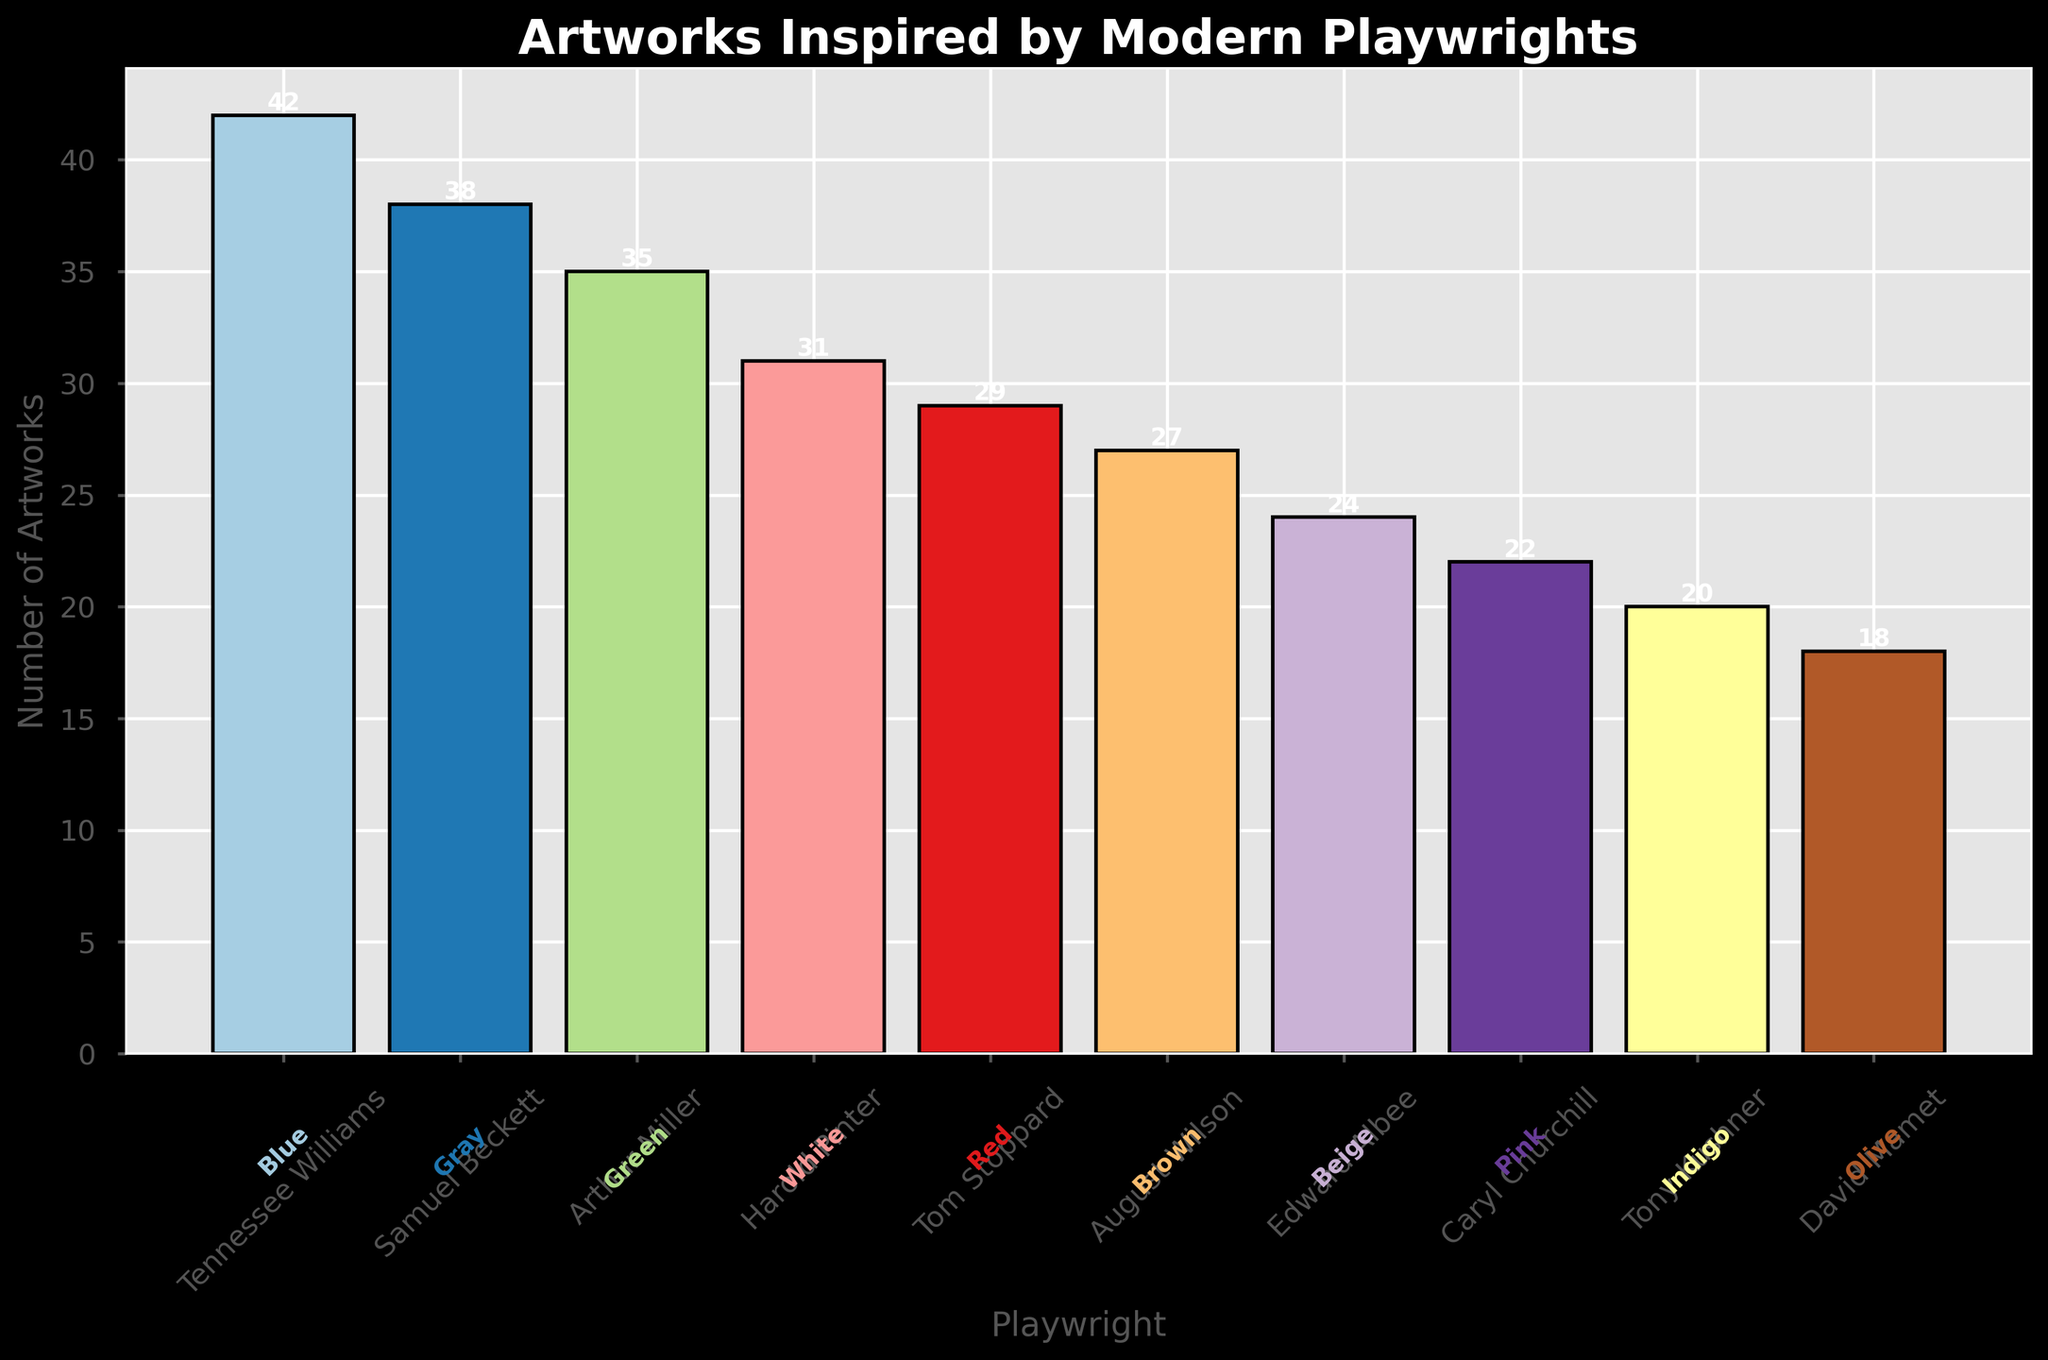Which playwright had the highest number of artworks? By closely observing the height of the bars, the tallest bar corresponds to Tennessee Williams.
Answer: Tennessee Williams Which playwright had the lowest number of artworks? By comparing the height of the bars, the shortest bar corresponds to David Mamet.
Answer: David Mamet How many more artworks are inspired by Tennessee Williams compared to Harold Pinter? Find the number of artworks for Tennessee Williams (42) and Harold Pinter (31), then subtract Pinter's count from Williams' count: 42 - 31.
Answer: 11 What is the total number of artworks inspired by plays from both Arthur Miller and Edward Albee? Add the number of artworks for Arthur Miller (35) and Edward Albee (24): 35 + 24.
Answer: 59 What is the average number of artworks inspired by the plays of the top three playwrights? Identify the top three playwrights by artworks (Tennessee Williams, Samuel Beckett, and Arthur Miller). Add their artworks (42, 38, 35) and divide by 3: (42 + 38 + 35) / 3.
Answer: 38.33 Which playwright's artworks are associated with the primary color "Red"? The legend or text at the base of the bar shows Tom Stoppard is associated with the primary color Red.
Answer: Tom Stoppard How does the number of artworks inspired by Harold Pinter compare to those by Caryl Churchill? The height of Harold Pinter's bar is higher than Caryl Churchill's bar. Specifically, 31 for Pinter compared to 22 for Churchill.
Answer: Harold Pinter has more Which three playwrights' artworks constitute the middle range in terms of numbers? Ranking the playwrights by the number of artworks, the middle values (4th, 5th, 6th highest) are Harold Pinter (31), Tom Stoppard (29), and August Wilson (27).
Answer: Harold Pinter, Tom Stoppard, August Wilson What is the primary color used for David Mamet’s artworks? The text annotation below David Mamet’s bar indicates his primary color as Olive.
Answer: Olive Whose artworks exhibit "Teal" as an accent color? By looking at the data label or color annotation, it shows that August Wilson's artworks use "Teal" as an accent color.
Answer: August Wilson 